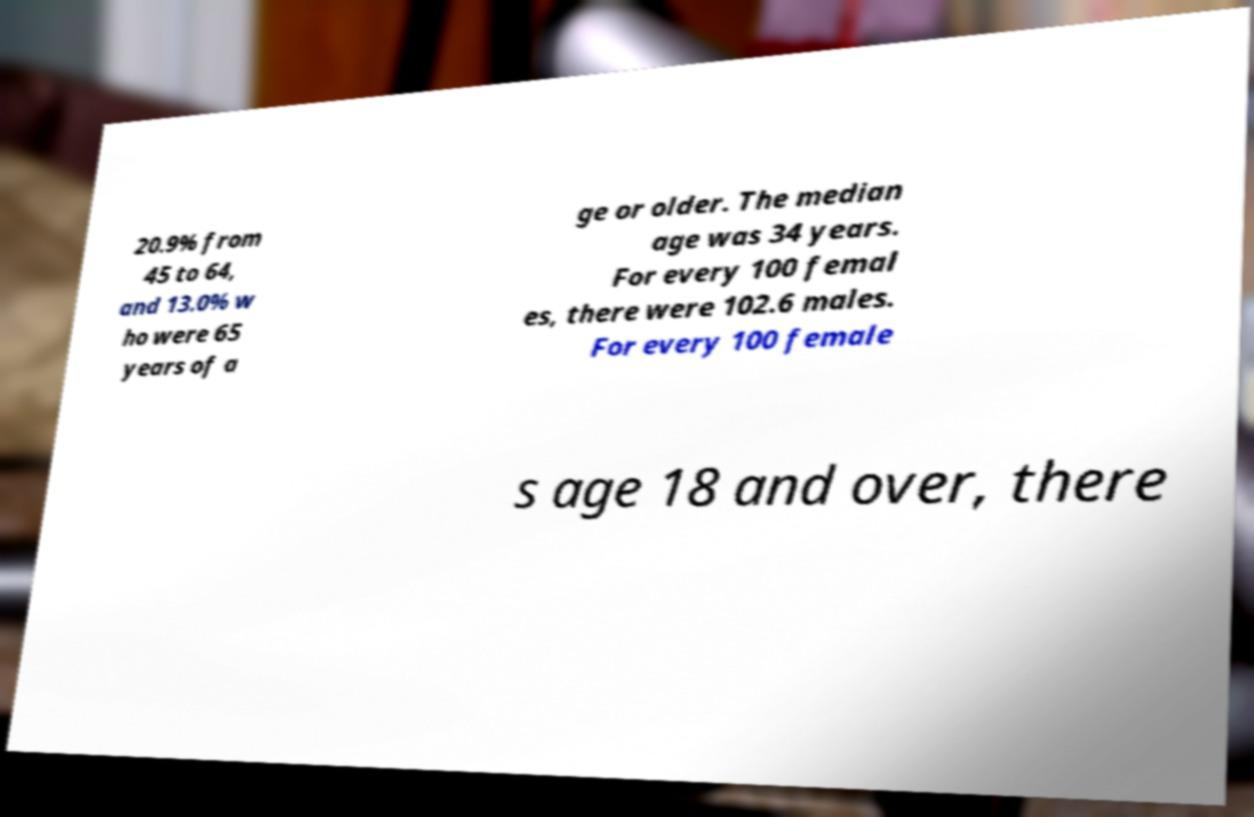What messages or text are displayed in this image? I need them in a readable, typed format. 20.9% from 45 to 64, and 13.0% w ho were 65 years of a ge or older. The median age was 34 years. For every 100 femal es, there were 102.6 males. For every 100 female s age 18 and over, there 